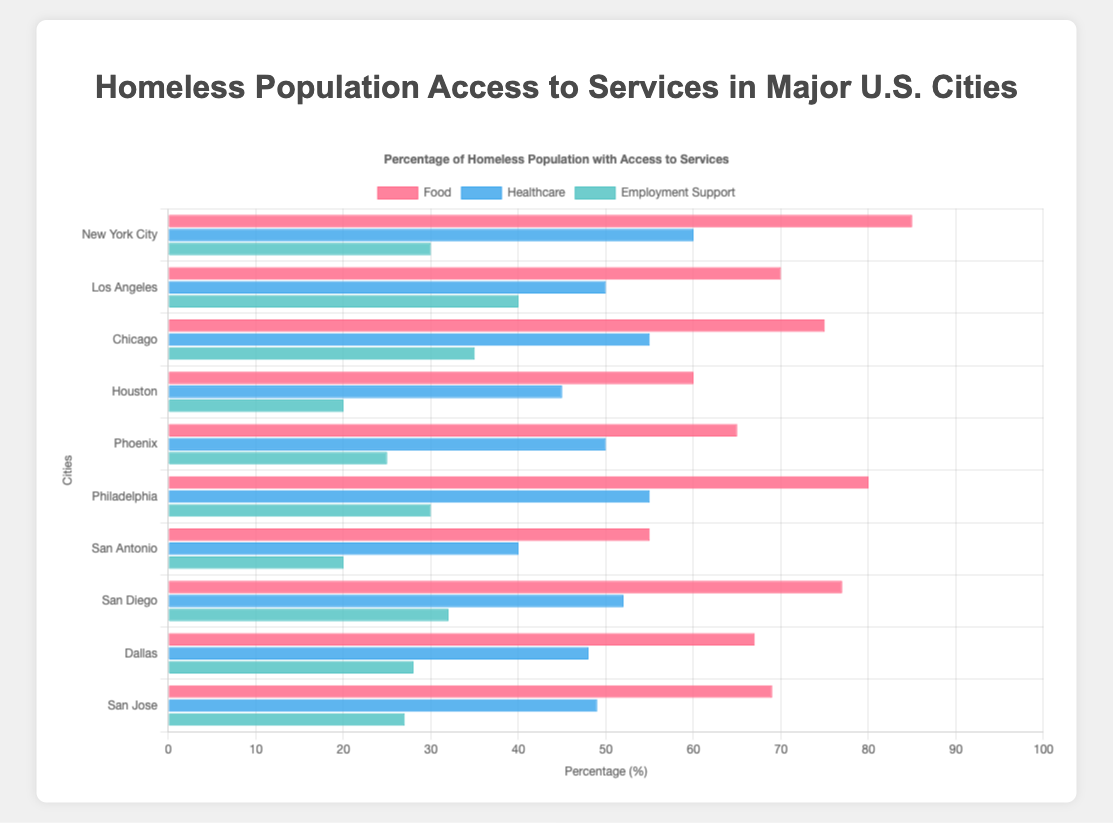Which city has the highest percentage of homeless population with access to food services? By looking at the bars colored in red, we can see that New York City has the highest bar, indicating the highest percentage of access to food services among the cities.
Answer: New York City How does the percentage of homeless population with access to employment support in Los Angeles compare to that in Houston? Compare the bars representing employment support (green color) for Los Angeles and Houston. Los Angeles has a bar at 40%, whereas Houston has a bar at 20%.
Answer: Los Angeles has 20% more What is the average percentage of homeless population with access to healthcare services across all cities? Sum the healthcare percentages (60, 50, 55, 45, 50, 55, 40, 52, 48, 49) and divide by the number of cities (10). That sums to 504, so 504/10 = 50.4
Answer: 50.4 Which city has the lowest percentage of homeless population with access to food services, and what is the value? Look for the smallest red bar among all the cities; San Antonio has the lowest bar with a value of 55%.
Answer: San Antonio, 55% Is there any city where the percentage of access to food services is lower than the percentage of access to healthcare services? Check each city to see if the red bar (food) is shorter than the blue bar (healthcare). In all cities, the red bar (food) is higher than the blue bar (healthcare), so there isn't any city where the access to food is less than the access to healthcare.
Answer: No What is the total percentage of homeless population with access to employment support when combined across New York City, Los Angeles, and Chicago? Sum the employment support percentages for New York City (30), Los Angeles (40), and Chicago (35). The total is 30 + 40 + 35 = 105.
Answer: 105 Which city has the most significant discrepancy between the highest and lowest percentage of access to different services? Calculate the difference between the maximum and minimum percentages for each city and find the largest difference. For New York City, it's 85 - 30 = 55; for Los Angeles, it's 70 - 40 = 30; for Chicago, it's 75 - 35 = 40; for Houston, it's 60 - 20 = 40; for Phoenix, it's 65 - 25 = 40; for Philadelphia, it's 80 - 30 = 50; for San Antonio, it's 55 - 20 = 35; for San Diego, it's 77 - 32 = 45; for Dallas, it's 67 - 28 = 39; for San Jose, it's 69 - 27 = 42. New York City has the largest discrepancy of 55.
Answer: New York City 